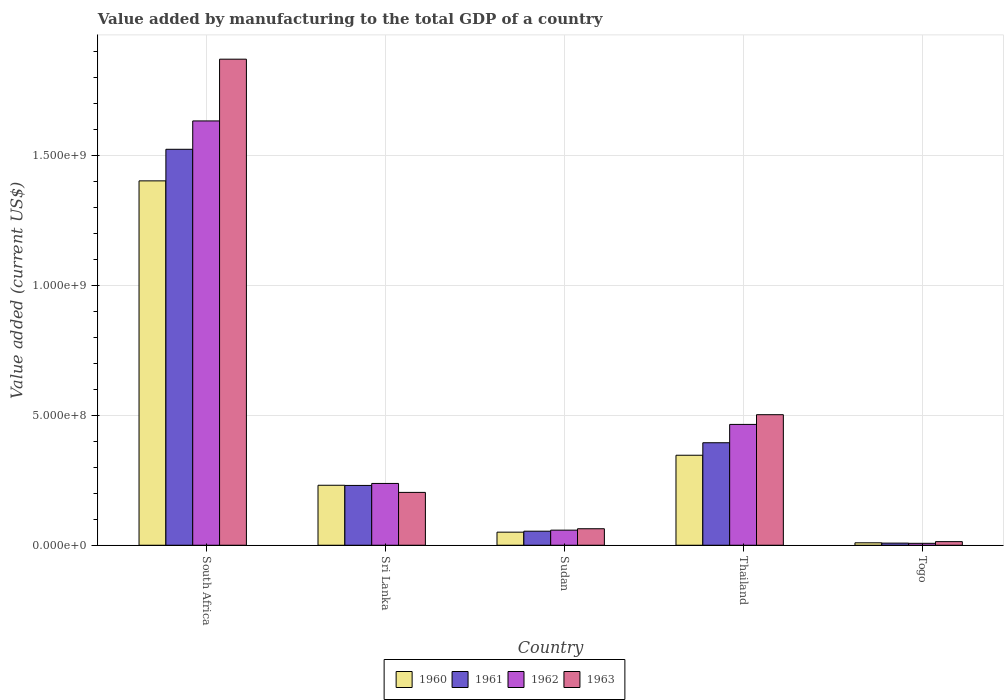How many groups of bars are there?
Your answer should be very brief. 5. Are the number of bars per tick equal to the number of legend labels?
Make the answer very short. Yes. Are the number of bars on each tick of the X-axis equal?
Your answer should be compact. Yes. How many bars are there on the 1st tick from the right?
Provide a short and direct response. 4. What is the label of the 2nd group of bars from the left?
Ensure brevity in your answer.  Sri Lanka. What is the value added by manufacturing to the total GDP in 1963 in South Africa?
Keep it short and to the point. 1.87e+09. Across all countries, what is the maximum value added by manufacturing to the total GDP in 1961?
Give a very brief answer. 1.52e+09. Across all countries, what is the minimum value added by manufacturing to the total GDP in 1962?
Ensure brevity in your answer.  7.35e+06. In which country was the value added by manufacturing to the total GDP in 1962 maximum?
Provide a short and direct response. South Africa. In which country was the value added by manufacturing to the total GDP in 1960 minimum?
Keep it short and to the point. Togo. What is the total value added by manufacturing to the total GDP in 1960 in the graph?
Your answer should be compact. 2.04e+09. What is the difference between the value added by manufacturing to the total GDP in 1962 in Sri Lanka and that in Togo?
Ensure brevity in your answer.  2.30e+08. What is the difference between the value added by manufacturing to the total GDP in 1962 in Thailand and the value added by manufacturing to the total GDP in 1961 in Togo?
Make the answer very short. 4.57e+08. What is the average value added by manufacturing to the total GDP in 1963 per country?
Make the answer very short. 5.30e+08. What is the difference between the value added by manufacturing to the total GDP of/in 1963 and value added by manufacturing to the total GDP of/in 1960 in Thailand?
Your answer should be very brief. 1.56e+08. In how many countries, is the value added by manufacturing to the total GDP in 1963 greater than 1300000000 US$?
Your response must be concise. 1. What is the ratio of the value added by manufacturing to the total GDP in 1961 in Thailand to that in Togo?
Offer a terse response. 48.34. Is the value added by manufacturing to the total GDP in 1961 in South Africa less than that in Thailand?
Offer a terse response. No. Is the difference between the value added by manufacturing to the total GDP in 1963 in South Africa and Sri Lanka greater than the difference between the value added by manufacturing to the total GDP in 1960 in South Africa and Sri Lanka?
Your answer should be very brief. Yes. What is the difference between the highest and the second highest value added by manufacturing to the total GDP in 1963?
Offer a very short reply. 1.67e+09. What is the difference between the highest and the lowest value added by manufacturing to the total GDP in 1962?
Make the answer very short. 1.62e+09. What does the 3rd bar from the left in Sri Lanka represents?
Provide a short and direct response. 1962. Is it the case that in every country, the sum of the value added by manufacturing to the total GDP in 1961 and value added by manufacturing to the total GDP in 1960 is greater than the value added by manufacturing to the total GDP in 1962?
Offer a terse response. Yes. How many bars are there?
Offer a very short reply. 20. Are all the bars in the graph horizontal?
Offer a terse response. No. How many countries are there in the graph?
Your answer should be very brief. 5. Does the graph contain any zero values?
Offer a very short reply. No. Does the graph contain grids?
Your answer should be compact. Yes. Where does the legend appear in the graph?
Your response must be concise. Bottom center. What is the title of the graph?
Give a very brief answer. Value added by manufacturing to the total GDP of a country. Does "1962" appear as one of the legend labels in the graph?
Keep it short and to the point. Yes. What is the label or title of the X-axis?
Offer a terse response. Country. What is the label or title of the Y-axis?
Provide a short and direct response. Value added (current US$). What is the Value added (current US$) in 1960 in South Africa?
Provide a short and direct response. 1.40e+09. What is the Value added (current US$) in 1961 in South Africa?
Make the answer very short. 1.52e+09. What is the Value added (current US$) of 1962 in South Africa?
Make the answer very short. 1.63e+09. What is the Value added (current US$) of 1963 in South Africa?
Keep it short and to the point. 1.87e+09. What is the Value added (current US$) in 1960 in Sri Lanka?
Offer a terse response. 2.31e+08. What is the Value added (current US$) in 1961 in Sri Lanka?
Offer a terse response. 2.30e+08. What is the Value added (current US$) in 1962 in Sri Lanka?
Offer a very short reply. 2.38e+08. What is the Value added (current US$) of 1963 in Sri Lanka?
Ensure brevity in your answer.  2.03e+08. What is the Value added (current US$) in 1960 in Sudan?
Offer a very short reply. 5.03e+07. What is the Value added (current US$) of 1961 in Sudan?
Provide a succinct answer. 5.40e+07. What is the Value added (current US$) in 1962 in Sudan?
Your answer should be very brief. 5.80e+07. What is the Value added (current US$) of 1963 in Sudan?
Your answer should be compact. 6.35e+07. What is the Value added (current US$) of 1960 in Thailand?
Keep it short and to the point. 3.46e+08. What is the Value added (current US$) of 1961 in Thailand?
Give a very brief answer. 3.94e+08. What is the Value added (current US$) in 1962 in Thailand?
Your answer should be very brief. 4.65e+08. What is the Value added (current US$) in 1963 in Thailand?
Offer a terse response. 5.02e+08. What is the Value added (current US$) of 1960 in Togo?
Offer a very short reply. 9.38e+06. What is the Value added (current US$) of 1961 in Togo?
Keep it short and to the point. 8.15e+06. What is the Value added (current US$) of 1962 in Togo?
Give a very brief answer. 7.35e+06. What is the Value added (current US$) of 1963 in Togo?
Make the answer very short. 1.39e+07. Across all countries, what is the maximum Value added (current US$) of 1960?
Your answer should be very brief. 1.40e+09. Across all countries, what is the maximum Value added (current US$) in 1961?
Your answer should be very brief. 1.52e+09. Across all countries, what is the maximum Value added (current US$) in 1962?
Offer a very short reply. 1.63e+09. Across all countries, what is the maximum Value added (current US$) in 1963?
Provide a succinct answer. 1.87e+09. Across all countries, what is the minimum Value added (current US$) in 1960?
Offer a very short reply. 9.38e+06. Across all countries, what is the minimum Value added (current US$) in 1961?
Provide a succinct answer. 8.15e+06. Across all countries, what is the minimum Value added (current US$) in 1962?
Make the answer very short. 7.35e+06. Across all countries, what is the minimum Value added (current US$) of 1963?
Offer a terse response. 1.39e+07. What is the total Value added (current US$) in 1960 in the graph?
Keep it short and to the point. 2.04e+09. What is the total Value added (current US$) of 1961 in the graph?
Offer a terse response. 2.21e+09. What is the total Value added (current US$) in 1962 in the graph?
Your answer should be compact. 2.40e+09. What is the total Value added (current US$) in 1963 in the graph?
Give a very brief answer. 2.65e+09. What is the difference between the Value added (current US$) of 1960 in South Africa and that in Sri Lanka?
Provide a short and direct response. 1.17e+09. What is the difference between the Value added (current US$) of 1961 in South Africa and that in Sri Lanka?
Provide a succinct answer. 1.29e+09. What is the difference between the Value added (current US$) of 1962 in South Africa and that in Sri Lanka?
Provide a succinct answer. 1.39e+09. What is the difference between the Value added (current US$) in 1963 in South Africa and that in Sri Lanka?
Provide a short and direct response. 1.67e+09. What is the difference between the Value added (current US$) in 1960 in South Africa and that in Sudan?
Give a very brief answer. 1.35e+09. What is the difference between the Value added (current US$) in 1961 in South Africa and that in Sudan?
Ensure brevity in your answer.  1.47e+09. What is the difference between the Value added (current US$) in 1962 in South Africa and that in Sudan?
Your answer should be compact. 1.57e+09. What is the difference between the Value added (current US$) of 1963 in South Africa and that in Sudan?
Give a very brief answer. 1.81e+09. What is the difference between the Value added (current US$) of 1960 in South Africa and that in Thailand?
Provide a short and direct response. 1.06e+09. What is the difference between the Value added (current US$) of 1961 in South Africa and that in Thailand?
Offer a very short reply. 1.13e+09. What is the difference between the Value added (current US$) in 1962 in South Africa and that in Thailand?
Offer a very short reply. 1.17e+09. What is the difference between the Value added (current US$) of 1963 in South Africa and that in Thailand?
Give a very brief answer. 1.37e+09. What is the difference between the Value added (current US$) in 1960 in South Africa and that in Togo?
Keep it short and to the point. 1.39e+09. What is the difference between the Value added (current US$) of 1961 in South Africa and that in Togo?
Offer a very short reply. 1.51e+09. What is the difference between the Value added (current US$) in 1962 in South Africa and that in Togo?
Your response must be concise. 1.62e+09. What is the difference between the Value added (current US$) in 1963 in South Africa and that in Togo?
Offer a terse response. 1.86e+09. What is the difference between the Value added (current US$) of 1960 in Sri Lanka and that in Sudan?
Give a very brief answer. 1.80e+08. What is the difference between the Value added (current US$) in 1961 in Sri Lanka and that in Sudan?
Offer a terse response. 1.76e+08. What is the difference between the Value added (current US$) in 1962 in Sri Lanka and that in Sudan?
Provide a succinct answer. 1.80e+08. What is the difference between the Value added (current US$) of 1963 in Sri Lanka and that in Sudan?
Offer a terse response. 1.40e+08. What is the difference between the Value added (current US$) in 1960 in Sri Lanka and that in Thailand?
Give a very brief answer. -1.15e+08. What is the difference between the Value added (current US$) in 1961 in Sri Lanka and that in Thailand?
Your response must be concise. -1.64e+08. What is the difference between the Value added (current US$) in 1962 in Sri Lanka and that in Thailand?
Your response must be concise. -2.27e+08. What is the difference between the Value added (current US$) of 1963 in Sri Lanka and that in Thailand?
Keep it short and to the point. -2.99e+08. What is the difference between the Value added (current US$) of 1960 in Sri Lanka and that in Togo?
Offer a very short reply. 2.21e+08. What is the difference between the Value added (current US$) of 1961 in Sri Lanka and that in Togo?
Your answer should be compact. 2.22e+08. What is the difference between the Value added (current US$) of 1962 in Sri Lanka and that in Togo?
Your answer should be very brief. 2.30e+08. What is the difference between the Value added (current US$) in 1963 in Sri Lanka and that in Togo?
Your answer should be compact. 1.89e+08. What is the difference between the Value added (current US$) of 1960 in Sudan and that in Thailand?
Offer a very short reply. -2.96e+08. What is the difference between the Value added (current US$) of 1961 in Sudan and that in Thailand?
Make the answer very short. -3.40e+08. What is the difference between the Value added (current US$) of 1962 in Sudan and that in Thailand?
Provide a succinct answer. -4.07e+08. What is the difference between the Value added (current US$) in 1963 in Sudan and that in Thailand?
Keep it short and to the point. -4.39e+08. What is the difference between the Value added (current US$) of 1960 in Sudan and that in Togo?
Give a very brief answer. 4.09e+07. What is the difference between the Value added (current US$) of 1961 in Sudan and that in Togo?
Offer a terse response. 4.58e+07. What is the difference between the Value added (current US$) in 1962 in Sudan and that in Togo?
Give a very brief answer. 5.07e+07. What is the difference between the Value added (current US$) in 1963 in Sudan and that in Togo?
Offer a terse response. 4.96e+07. What is the difference between the Value added (current US$) of 1960 in Thailand and that in Togo?
Your answer should be very brief. 3.37e+08. What is the difference between the Value added (current US$) in 1961 in Thailand and that in Togo?
Your answer should be compact. 3.86e+08. What is the difference between the Value added (current US$) of 1962 in Thailand and that in Togo?
Make the answer very short. 4.57e+08. What is the difference between the Value added (current US$) of 1963 in Thailand and that in Togo?
Your answer should be very brief. 4.88e+08. What is the difference between the Value added (current US$) of 1960 in South Africa and the Value added (current US$) of 1961 in Sri Lanka?
Provide a short and direct response. 1.17e+09. What is the difference between the Value added (current US$) of 1960 in South Africa and the Value added (current US$) of 1962 in Sri Lanka?
Offer a very short reply. 1.16e+09. What is the difference between the Value added (current US$) of 1960 in South Africa and the Value added (current US$) of 1963 in Sri Lanka?
Your response must be concise. 1.20e+09. What is the difference between the Value added (current US$) in 1961 in South Africa and the Value added (current US$) in 1962 in Sri Lanka?
Provide a succinct answer. 1.29e+09. What is the difference between the Value added (current US$) in 1961 in South Africa and the Value added (current US$) in 1963 in Sri Lanka?
Your answer should be very brief. 1.32e+09. What is the difference between the Value added (current US$) in 1962 in South Africa and the Value added (current US$) in 1963 in Sri Lanka?
Provide a short and direct response. 1.43e+09. What is the difference between the Value added (current US$) in 1960 in South Africa and the Value added (current US$) in 1961 in Sudan?
Your response must be concise. 1.35e+09. What is the difference between the Value added (current US$) of 1960 in South Africa and the Value added (current US$) of 1962 in Sudan?
Your answer should be compact. 1.34e+09. What is the difference between the Value added (current US$) in 1960 in South Africa and the Value added (current US$) in 1963 in Sudan?
Your answer should be very brief. 1.34e+09. What is the difference between the Value added (current US$) of 1961 in South Africa and the Value added (current US$) of 1962 in Sudan?
Provide a short and direct response. 1.46e+09. What is the difference between the Value added (current US$) of 1961 in South Africa and the Value added (current US$) of 1963 in Sudan?
Offer a terse response. 1.46e+09. What is the difference between the Value added (current US$) of 1962 in South Africa and the Value added (current US$) of 1963 in Sudan?
Keep it short and to the point. 1.57e+09. What is the difference between the Value added (current US$) in 1960 in South Africa and the Value added (current US$) in 1961 in Thailand?
Provide a short and direct response. 1.01e+09. What is the difference between the Value added (current US$) in 1960 in South Africa and the Value added (current US$) in 1962 in Thailand?
Your answer should be compact. 9.37e+08. What is the difference between the Value added (current US$) in 1960 in South Africa and the Value added (current US$) in 1963 in Thailand?
Make the answer very short. 8.99e+08. What is the difference between the Value added (current US$) in 1961 in South Africa and the Value added (current US$) in 1962 in Thailand?
Make the answer very short. 1.06e+09. What is the difference between the Value added (current US$) in 1961 in South Africa and the Value added (current US$) in 1963 in Thailand?
Make the answer very short. 1.02e+09. What is the difference between the Value added (current US$) of 1962 in South Africa and the Value added (current US$) of 1963 in Thailand?
Your answer should be compact. 1.13e+09. What is the difference between the Value added (current US$) of 1960 in South Africa and the Value added (current US$) of 1961 in Togo?
Keep it short and to the point. 1.39e+09. What is the difference between the Value added (current US$) in 1960 in South Africa and the Value added (current US$) in 1962 in Togo?
Your response must be concise. 1.39e+09. What is the difference between the Value added (current US$) in 1960 in South Africa and the Value added (current US$) in 1963 in Togo?
Your answer should be compact. 1.39e+09. What is the difference between the Value added (current US$) in 1961 in South Africa and the Value added (current US$) in 1962 in Togo?
Give a very brief answer. 1.52e+09. What is the difference between the Value added (current US$) of 1961 in South Africa and the Value added (current US$) of 1963 in Togo?
Keep it short and to the point. 1.51e+09. What is the difference between the Value added (current US$) of 1962 in South Africa and the Value added (current US$) of 1963 in Togo?
Your answer should be compact. 1.62e+09. What is the difference between the Value added (current US$) in 1960 in Sri Lanka and the Value added (current US$) in 1961 in Sudan?
Keep it short and to the point. 1.77e+08. What is the difference between the Value added (current US$) in 1960 in Sri Lanka and the Value added (current US$) in 1962 in Sudan?
Make the answer very short. 1.73e+08. What is the difference between the Value added (current US$) of 1960 in Sri Lanka and the Value added (current US$) of 1963 in Sudan?
Your response must be concise. 1.67e+08. What is the difference between the Value added (current US$) in 1961 in Sri Lanka and the Value added (current US$) in 1962 in Sudan?
Offer a very short reply. 1.72e+08. What is the difference between the Value added (current US$) of 1961 in Sri Lanka and the Value added (current US$) of 1963 in Sudan?
Give a very brief answer. 1.67e+08. What is the difference between the Value added (current US$) in 1962 in Sri Lanka and the Value added (current US$) in 1963 in Sudan?
Provide a succinct answer. 1.74e+08. What is the difference between the Value added (current US$) in 1960 in Sri Lanka and the Value added (current US$) in 1961 in Thailand?
Keep it short and to the point. -1.64e+08. What is the difference between the Value added (current US$) in 1960 in Sri Lanka and the Value added (current US$) in 1962 in Thailand?
Offer a terse response. -2.34e+08. What is the difference between the Value added (current US$) in 1960 in Sri Lanka and the Value added (current US$) in 1963 in Thailand?
Provide a succinct answer. -2.71e+08. What is the difference between the Value added (current US$) of 1961 in Sri Lanka and the Value added (current US$) of 1962 in Thailand?
Provide a short and direct response. -2.35e+08. What is the difference between the Value added (current US$) of 1961 in Sri Lanka and the Value added (current US$) of 1963 in Thailand?
Ensure brevity in your answer.  -2.72e+08. What is the difference between the Value added (current US$) of 1962 in Sri Lanka and the Value added (current US$) of 1963 in Thailand?
Ensure brevity in your answer.  -2.64e+08. What is the difference between the Value added (current US$) in 1960 in Sri Lanka and the Value added (current US$) in 1961 in Togo?
Keep it short and to the point. 2.23e+08. What is the difference between the Value added (current US$) of 1960 in Sri Lanka and the Value added (current US$) of 1962 in Togo?
Provide a short and direct response. 2.23e+08. What is the difference between the Value added (current US$) in 1960 in Sri Lanka and the Value added (current US$) in 1963 in Togo?
Your answer should be very brief. 2.17e+08. What is the difference between the Value added (current US$) of 1961 in Sri Lanka and the Value added (current US$) of 1962 in Togo?
Your response must be concise. 2.23e+08. What is the difference between the Value added (current US$) in 1961 in Sri Lanka and the Value added (current US$) in 1963 in Togo?
Your answer should be very brief. 2.16e+08. What is the difference between the Value added (current US$) of 1962 in Sri Lanka and the Value added (current US$) of 1963 in Togo?
Provide a succinct answer. 2.24e+08. What is the difference between the Value added (current US$) in 1960 in Sudan and the Value added (current US$) in 1961 in Thailand?
Your response must be concise. -3.44e+08. What is the difference between the Value added (current US$) in 1960 in Sudan and the Value added (current US$) in 1962 in Thailand?
Offer a very short reply. -4.14e+08. What is the difference between the Value added (current US$) of 1960 in Sudan and the Value added (current US$) of 1963 in Thailand?
Your answer should be compact. -4.52e+08. What is the difference between the Value added (current US$) in 1961 in Sudan and the Value added (current US$) in 1962 in Thailand?
Offer a terse response. -4.11e+08. What is the difference between the Value added (current US$) of 1961 in Sudan and the Value added (current US$) of 1963 in Thailand?
Provide a succinct answer. -4.48e+08. What is the difference between the Value added (current US$) in 1962 in Sudan and the Value added (current US$) in 1963 in Thailand?
Offer a very short reply. -4.44e+08. What is the difference between the Value added (current US$) of 1960 in Sudan and the Value added (current US$) of 1961 in Togo?
Ensure brevity in your answer.  4.21e+07. What is the difference between the Value added (current US$) of 1960 in Sudan and the Value added (current US$) of 1962 in Togo?
Give a very brief answer. 4.29e+07. What is the difference between the Value added (current US$) in 1960 in Sudan and the Value added (current US$) in 1963 in Togo?
Your response must be concise. 3.64e+07. What is the difference between the Value added (current US$) of 1961 in Sudan and the Value added (current US$) of 1962 in Togo?
Offer a terse response. 4.66e+07. What is the difference between the Value added (current US$) of 1961 in Sudan and the Value added (current US$) of 1963 in Togo?
Keep it short and to the point. 4.01e+07. What is the difference between the Value added (current US$) in 1962 in Sudan and the Value added (current US$) in 1963 in Togo?
Your response must be concise. 4.41e+07. What is the difference between the Value added (current US$) in 1960 in Thailand and the Value added (current US$) in 1961 in Togo?
Offer a terse response. 3.38e+08. What is the difference between the Value added (current US$) of 1960 in Thailand and the Value added (current US$) of 1962 in Togo?
Your response must be concise. 3.39e+08. What is the difference between the Value added (current US$) in 1960 in Thailand and the Value added (current US$) in 1963 in Togo?
Make the answer very short. 3.32e+08. What is the difference between the Value added (current US$) of 1961 in Thailand and the Value added (current US$) of 1962 in Togo?
Provide a short and direct response. 3.87e+08. What is the difference between the Value added (current US$) in 1961 in Thailand and the Value added (current US$) in 1963 in Togo?
Give a very brief answer. 3.80e+08. What is the difference between the Value added (current US$) in 1962 in Thailand and the Value added (current US$) in 1963 in Togo?
Make the answer very short. 4.51e+08. What is the average Value added (current US$) of 1960 per country?
Provide a succinct answer. 4.08e+08. What is the average Value added (current US$) in 1961 per country?
Provide a succinct answer. 4.42e+08. What is the average Value added (current US$) of 1962 per country?
Your response must be concise. 4.80e+08. What is the average Value added (current US$) of 1963 per country?
Provide a short and direct response. 5.30e+08. What is the difference between the Value added (current US$) in 1960 and Value added (current US$) in 1961 in South Africa?
Your answer should be very brief. -1.21e+08. What is the difference between the Value added (current US$) in 1960 and Value added (current US$) in 1962 in South Africa?
Offer a very short reply. -2.31e+08. What is the difference between the Value added (current US$) in 1960 and Value added (current US$) in 1963 in South Africa?
Provide a succinct answer. -4.68e+08. What is the difference between the Value added (current US$) of 1961 and Value added (current US$) of 1962 in South Africa?
Your answer should be very brief. -1.09e+08. What is the difference between the Value added (current US$) in 1961 and Value added (current US$) in 1963 in South Africa?
Offer a terse response. -3.47e+08. What is the difference between the Value added (current US$) of 1962 and Value added (current US$) of 1963 in South Africa?
Make the answer very short. -2.37e+08. What is the difference between the Value added (current US$) in 1960 and Value added (current US$) in 1961 in Sri Lanka?
Offer a very short reply. 6.30e+05. What is the difference between the Value added (current US$) in 1960 and Value added (current US$) in 1962 in Sri Lanka?
Your answer should be compact. -6.98e+06. What is the difference between the Value added (current US$) of 1960 and Value added (current US$) of 1963 in Sri Lanka?
Your response must be concise. 2.75e+07. What is the difference between the Value added (current US$) in 1961 and Value added (current US$) in 1962 in Sri Lanka?
Provide a succinct answer. -7.61e+06. What is the difference between the Value added (current US$) in 1961 and Value added (current US$) in 1963 in Sri Lanka?
Make the answer very short. 2.68e+07. What is the difference between the Value added (current US$) in 1962 and Value added (current US$) in 1963 in Sri Lanka?
Your response must be concise. 3.45e+07. What is the difference between the Value added (current US$) of 1960 and Value added (current US$) of 1961 in Sudan?
Provide a short and direct response. -3.73e+06. What is the difference between the Value added (current US$) in 1960 and Value added (current US$) in 1962 in Sudan?
Give a very brief answer. -7.75e+06. What is the difference between the Value added (current US$) in 1960 and Value added (current US$) in 1963 in Sudan?
Your answer should be compact. -1.32e+07. What is the difference between the Value added (current US$) of 1961 and Value added (current US$) of 1962 in Sudan?
Your response must be concise. -4.02e+06. What is the difference between the Value added (current US$) of 1961 and Value added (current US$) of 1963 in Sudan?
Make the answer very short. -9.48e+06. What is the difference between the Value added (current US$) in 1962 and Value added (current US$) in 1963 in Sudan?
Provide a short and direct response. -5.46e+06. What is the difference between the Value added (current US$) in 1960 and Value added (current US$) in 1961 in Thailand?
Keep it short and to the point. -4.81e+07. What is the difference between the Value added (current US$) in 1960 and Value added (current US$) in 1962 in Thailand?
Keep it short and to the point. -1.19e+08. What is the difference between the Value added (current US$) of 1960 and Value added (current US$) of 1963 in Thailand?
Your response must be concise. -1.56e+08. What is the difference between the Value added (current US$) in 1961 and Value added (current US$) in 1962 in Thailand?
Your answer should be compact. -7.05e+07. What is the difference between the Value added (current US$) of 1961 and Value added (current US$) of 1963 in Thailand?
Your answer should be very brief. -1.08e+08. What is the difference between the Value added (current US$) of 1962 and Value added (current US$) of 1963 in Thailand?
Provide a short and direct response. -3.73e+07. What is the difference between the Value added (current US$) of 1960 and Value added (current US$) of 1961 in Togo?
Your response must be concise. 1.23e+06. What is the difference between the Value added (current US$) of 1960 and Value added (current US$) of 1962 in Togo?
Make the answer very short. 2.03e+06. What is the difference between the Value added (current US$) of 1960 and Value added (current US$) of 1963 in Togo?
Ensure brevity in your answer.  -4.50e+06. What is the difference between the Value added (current US$) of 1961 and Value added (current US$) of 1962 in Togo?
Offer a terse response. 8.08e+05. What is the difference between the Value added (current US$) of 1961 and Value added (current US$) of 1963 in Togo?
Offer a very short reply. -5.72e+06. What is the difference between the Value added (current US$) of 1962 and Value added (current US$) of 1963 in Togo?
Make the answer very short. -6.53e+06. What is the ratio of the Value added (current US$) in 1960 in South Africa to that in Sri Lanka?
Your answer should be very brief. 6.08. What is the ratio of the Value added (current US$) in 1961 in South Africa to that in Sri Lanka?
Make the answer very short. 6.62. What is the ratio of the Value added (current US$) of 1962 in South Africa to that in Sri Lanka?
Provide a succinct answer. 6.87. What is the ratio of the Value added (current US$) in 1963 in South Africa to that in Sri Lanka?
Ensure brevity in your answer.  9.2. What is the ratio of the Value added (current US$) in 1960 in South Africa to that in Sudan?
Your answer should be very brief. 27.88. What is the ratio of the Value added (current US$) of 1961 in South Africa to that in Sudan?
Provide a succinct answer. 28.21. What is the ratio of the Value added (current US$) of 1962 in South Africa to that in Sudan?
Provide a short and direct response. 28.13. What is the ratio of the Value added (current US$) of 1963 in South Africa to that in Sudan?
Your answer should be very brief. 29.45. What is the ratio of the Value added (current US$) of 1960 in South Africa to that in Thailand?
Give a very brief answer. 4.05. What is the ratio of the Value added (current US$) of 1961 in South Africa to that in Thailand?
Make the answer very short. 3.86. What is the ratio of the Value added (current US$) in 1962 in South Africa to that in Thailand?
Offer a terse response. 3.51. What is the ratio of the Value added (current US$) in 1963 in South Africa to that in Thailand?
Your answer should be compact. 3.72. What is the ratio of the Value added (current US$) in 1960 in South Africa to that in Togo?
Offer a very short reply. 149.4. What is the ratio of the Value added (current US$) in 1961 in South Africa to that in Togo?
Provide a succinct answer. 186.75. What is the ratio of the Value added (current US$) in 1962 in South Africa to that in Togo?
Your answer should be very brief. 222.14. What is the ratio of the Value added (current US$) in 1963 in South Africa to that in Togo?
Your answer should be very brief. 134.72. What is the ratio of the Value added (current US$) in 1960 in Sri Lanka to that in Sudan?
Give a very brief answer. 4.59. What is the ratio of the Value added (current US$) of 1961 in Sri Lanka to that in Sudan?
Give a very brief answer. 4.26. What is the ratio of the Value added (current US$) in 1962 in Sri Lanka to that in Sudan?
Offer a terse response. 4.1. What is the ratio of the Value added (current US$) in 1963 in Sri Lanka to that in Sudan?
Provide a short and direct response. 3.2. What is the ratio of the Value added (current US$) of 1960 in Sri Lanka to that in Thailand?
Offer a very short reply. 0.67. What is the ratio of the Value added (current US$) in 1961 in Sri Lanka to that in Thailand?
Ensure brevity in your answer.  0.58. What is the ratio of the Value added (current US$) of 1962 in Sri Lanka to that in Thailand?
Keep it short and to the point. 0.51. What is the ratio of the Value added (current US$) in 1963 in Sri Lanka to that in Thailand?
Give a very brief answer. 0.4. What is the ratio of the Value added (current US$) of 1960 in Sri Lanka to that in Togo?
Your answer should be compact. 24.59. What is the ratio of the Value added (current US$) in 1961 in Sri Lanka to that in Togo?
Give a very brief answer. 28.21. What is the ratio of the Value added (current US$) in 1962 in Sri Lanka to that in Togo?
Ensure brevity in your answer.  32.35. What is the ratio of the Value added (current US$) of 1963 in Sri Lanka to that in Togo?
Your answer should be compact. 14.64. What is the ratio of the Value added (current US$) in 1960 in Sudan to that in Thailand?
Your response must be concise. 0.15. What is the ratio of the Value added (current US$) of 1961 in Sudan to that in Thailand?
Offer a very short reply. 0.14. What is the ratio of the Value added (current US$) of 1962 in Sudan to that in Thailand?
Offer a terse response. 0.12. What is the ratio of the Value added (current US$) of 1963 in Sudan to that in Thailand?
Your response must be concise. 0.13. What is the ratio of the Value added (current US$) in 1960 in Sudan to that in Togo?
Ensure brevity in your answer.  5.36. What is the ratio of the Value added (current US$) in 1961 in Sudan to that in Togo?
Give a very brief answer. 6.62. What is the ratio of the Value added (current US$) in 1962 in Sudan to that in Togo?
Give a very brief answer. 7.9. What is the ratio of the Value added (current US$) of 1963 in Sudan to that in Togo?
Your answer should be very brief. 4.57. What is the ratio of the Value added (current US$) in 1960 in Thailand to that in Togo?
Your answer should be compact. 36.9. What is the ratio of the Value added (current US$) in 1961 in Thailand to that in Togo?
Make the answer very short. 48.34. What is the ratio of the Value added (current US$) in 1962 in Thailand to that in Togo?
Your answer should be very brief. 63.26. What is the ratio of the Value added (current US$) in 1963 in Thailand to that in Togo?
Your answer should be compact. 36.18. What is the difference between the highest and the second highest Value added (current US$) in 1960?
Your answer should be compact. 1.06e+09. What is the difference between the highest and the second highest Value added (current US$) of 1961?
Provide a short and direct response. 1.13e+09. What is the difference between the highest and the second highest Value added (current US$) of 1962?
Keep it short and to the point. 1.17e+09. What is the difference between the highest and the second highest Value added (current US$) in 1963?
Offer a very short reply. 1.37e+09. What is the difference between the highest and the lowest Value added (current US$) in 1960?
Offer a terse response. 1.39e+09. What is the difference between the highest and the lowest Value added (current US$) in 1961?
Keep it short and to the point. 1.51e+09. What is the difference between the highest and the lowest Value added (current US$) in 1962?
Your response must be concise. 1.62e+09. What is the difference between the highest and the lowest Value added (current US$) of 1963?
Make the answer very short. 1.86e+09. 